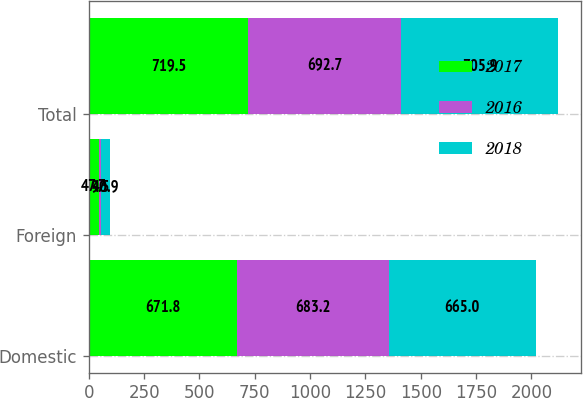<chart> <loc_0><loc_0><loc_500><loc_500><stacked_bar_chart><ecel><fcel>Domestic<fcel>Foreign<fcel>Total<nl><fcel>2017<fcel>671.8<fcel>47.7<fcel>719.5<nl><fcel>2016<fcel>683.2<fcel>9.5<fcel>692.7<nl><fcel>2018<fcel>665<fcel>40.9<fcel>705.9<nl></chart> 